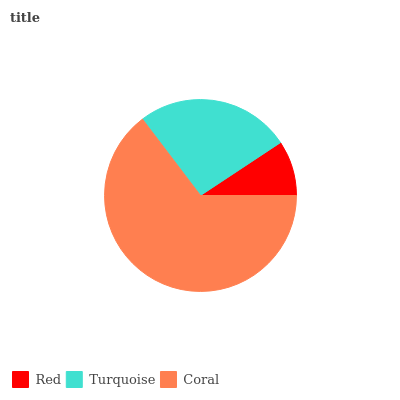Is Red the minimum?
Answer yes or no. Yes. Is Coral the maximum?
Answer yes or no. Yes. Is Turquoise the minimum?
Answer yes or no. No. Is Turquoise the maximum?
Answer yes or no. No. Is Turquoise greater than Red?
Answer yes or no. Yes. Is Red less than Turquoise?
Answer yes or no. Yes. Is Red greater than Turquoise?
Answer yes or no. No. Is Turquoise less than Red?
Answer yes or no. No. Is Turquoise the high median?
Answer yes or no. Yes. Is Turquoise the low median?
Answer yes or no. Yes. Is Coral the high median?
Answer yes or no. No. Is Coral the low median?
Answer yes or no. No. 